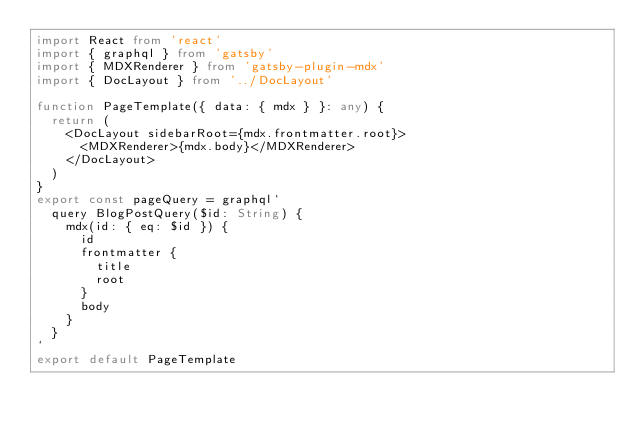<code> <loc_0><loc_0><loc_500><loc_500><_TypeScript_>import React from 'react'
import { graphql } from 'gatsby'
import { MDXRenderer } from 'gatsby-plugin-mdx'
import { DocLayout } from '../DocLayout'

function PageTemplate({ data: { mdx } }: any) {
  return (
    <DocLayout sidebarRoot={mdx.frontmatter.root}>
      <MDXRenderer>{mdx.body}</MDXRenderer>
    </DocLayout>
  )
}
export const pageQuery = graphql`
  query BlogPostQuery($id: String) {
    mdx(id: { eq: $id }) {
      id
      frontmatter {
        title
        root
      }
      body
    }
  }
`
export default PageTemplate
</code> 